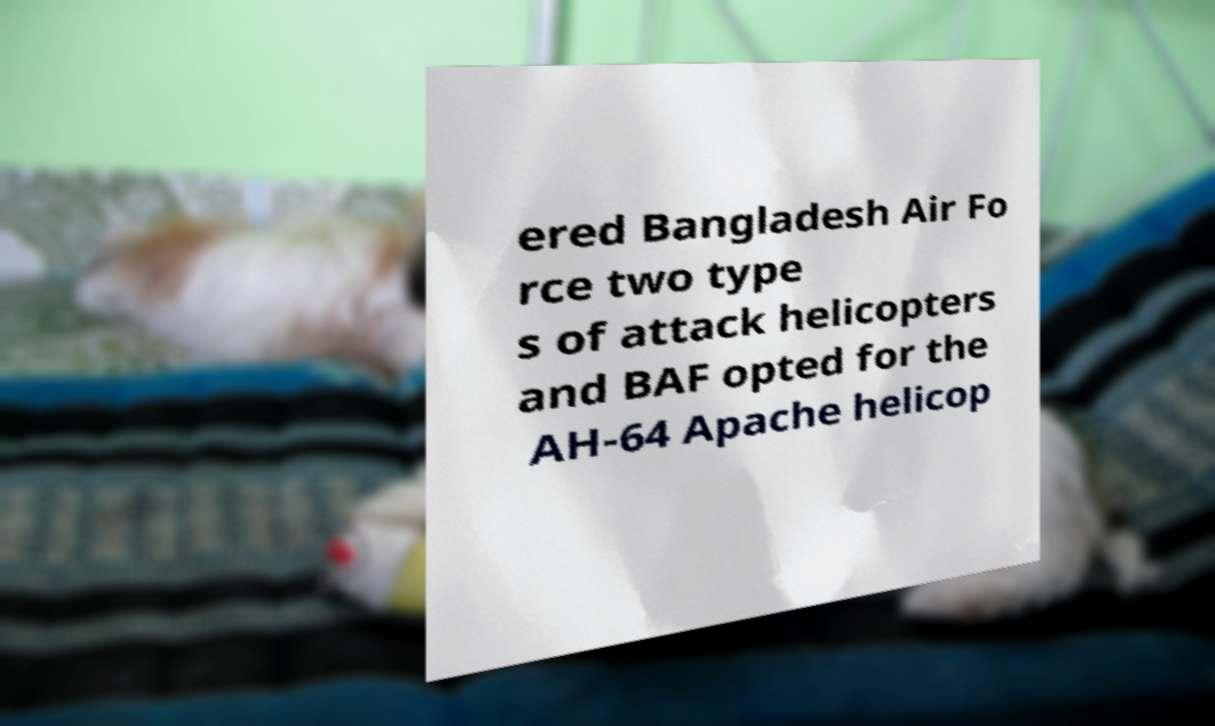Can you read and provide the text displayed in the image?This photo seems to have some interesting text. Can you extract and type it out for me? ered Bangladesh Air Fo rce two type s of attack helicopters and BAF opted for the AH-64 Apache helicop 